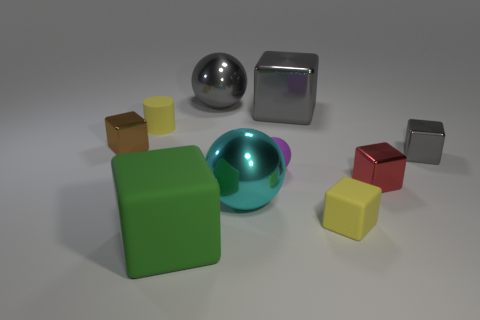Subtract all big gray blocks. How many blocks are left? 5 Subtract all balls. How many objects are left? 7 Subtract 2 spheres. How many spheres are left? 1 Subtract all cyan balls. How many balls are left? 2 Subtract all yellow matte objects. Subtract all brown shiny things. How many objects are left? 7 Add 1 tiny matte cylinders. How many tiny matte cylinders are left? 2 Add 1 small red metallic objects. How many small red metallic objects exist? 2 Subtract 1 yellow cylinders. How many objects are left? 9 Subtract all purple cubes. Subtract all brown balls. How many cubes are left? 6 Subtract all green cylinders. How many brown balls are left? 0 